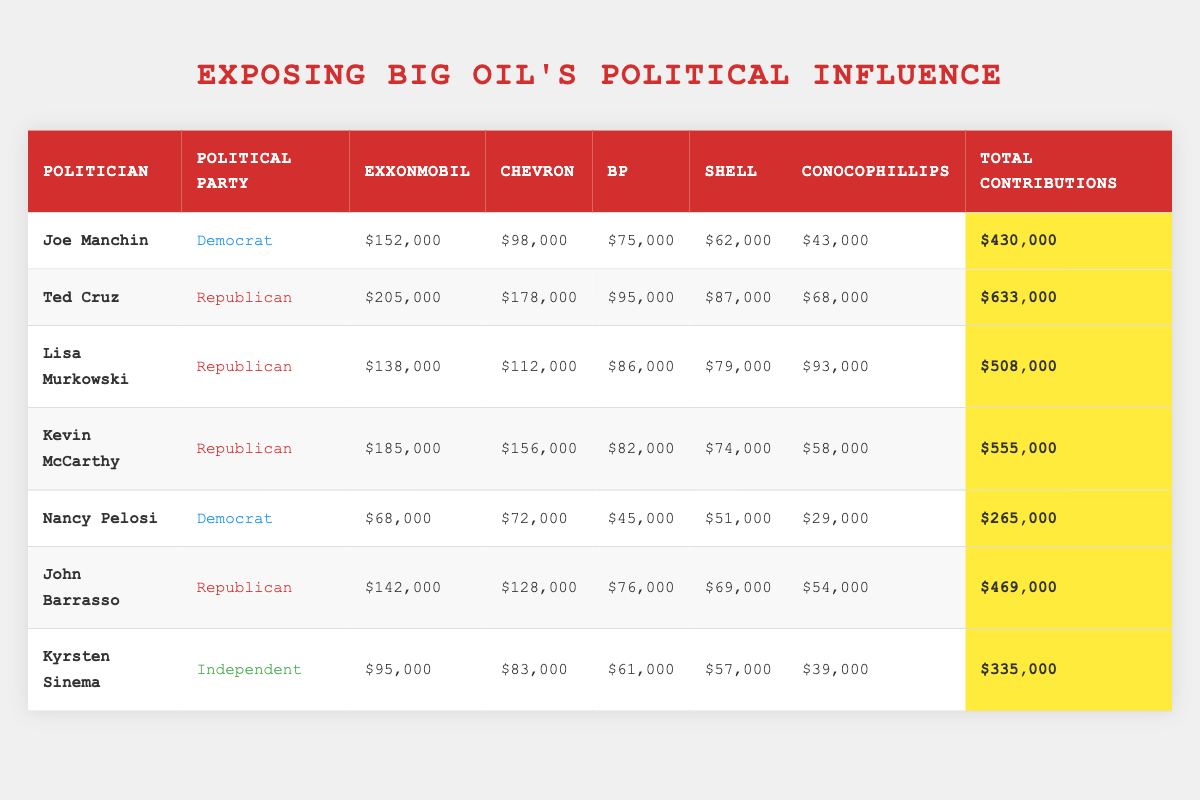What is the total contribution amount from ExxonMobil for Ted Cruz? The table shows that the contribution from ExxonMobil to Ted Cruz is $205,000.
Answer: $205,000 Who received the highest total contributions among the politicians listed? By checking the "Total Contributions" column, Ted Cruz has the highest total contributions at $633,000.
Answer: Ted Cruz Is Nancy Pelosi a Democrat based on her political affiliation in the table? The table indicates that Nancy Pelosi is listed as a Democrat in the "Political Party" column.
Answer: Yes What is the average total contribution amount for Republican politicians? The total contributions for the Republican politicians are Ted Cruz ($633,000), Lisa Murkowski ($508,000), Kevin McCarthy ($555,000), and John Barrasso ($469,000). Summing these gives $2,365,000. There are 4 Republicans, so the average is $2,365,000 / 4 = $591,250.
Answer: $591,250 Which politician received the least total contributions and how much did they receive? Reviewing the "Total Contributions" column, Nancy Pelosi has the least total contributions at $265,000.
Answer: Nancy Pelosi, $265,000 How much did ExxonMobil contribute in total to the two Democratic politicians (Joe Manchin and Nancy Pelosi)? Joe Manchin received $152,000 from ExxonMobil and Nancy Pelosi received $68,000. Adding these amounts gives $152,000 + $68,000 = $220,000.
Answer: $220,000 Does Kevin McCarthy have more contributions from Chevron than Joe Manchin? Kevin McCarthy received $156,000 from Chevron while Joe Manchin received $98,000 from the same company. Since $156,000 is greater than $98,000, the answer is yes.
Answer: Yes What is the difference in total contributions between the Republican with the highest total contributions and the one with the lowest total contributions? The Republican with the highest contributions is Ted Cruz ($633,000) and the lowest is John Barrasso ($469,000). The difference is $633,000 - $469,000 = $164,000.
Answer: $164,000 What is the total contribution from Shell for all politicians listed? From the table, the contributions from Shell are as follows: Joe Manchin ($62,000), Ted Cruz ($87,000), Lisa Murkowski ($79,000), Kevin McCarthy ($74,000), Nancy Pelosi ($51,000), John Barrasso ($69,000), and Kyrsten Sinema ($57,000). Adding these amounts gives $62,000 + $87,000 + $79,000 + $74,000 + $51,000 + $69,000 + $57,000 = $479,000.
Answer: $479,000 